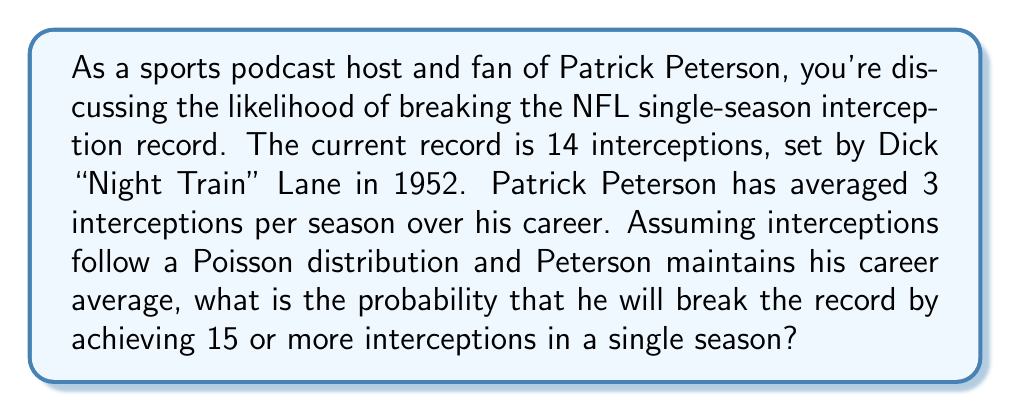Show me your answer to this math problem. To solve this problem, we'll use the Poisson distribution, which is appropriate for modeling rare events over a fixed interval (in this case, interceptions over a season).

1. The Poisson distribution is given by the formula:

   $$P(X = k) = \frac{e^{-\lambda} \lambda^k}{k!}$$

   where $\lambda$ is the average rate of occurrence and $k$ is the number of occurrences.

2. In this case, $\lambda = 3$ (Peterson's average interceptions per season).

3. We need to find $P(X \geq 15)$, which is the same as $1 - P(X \leq 14)$.

4. Using the cumulative Poisson distribution function:

   $$P(X \leq 14) = \sum_{k=0}^{14} \frac{e^{-3} 3^k}{k!}$$

5. This sum can be calculated using statistical software or a calculator with a Poisson cumulative distribution function. The result is approximately 0.999997.

6. Therefore, $P(X \geq 15) = 1 - 0.999997 = 0.000003$

This extremely small probability reflects the difficulty of breaking this long-standing NFL record, especially for a player with Peterson's average interception rate.
Answer: The probability of Patrick Peterson breaking the NFL single-season interception record by achieving 15 or more interceptions in a single season, given his career average of 3 interceptions per season, is approximately $3 \times 10^{-6}$ or 0.0003%. 